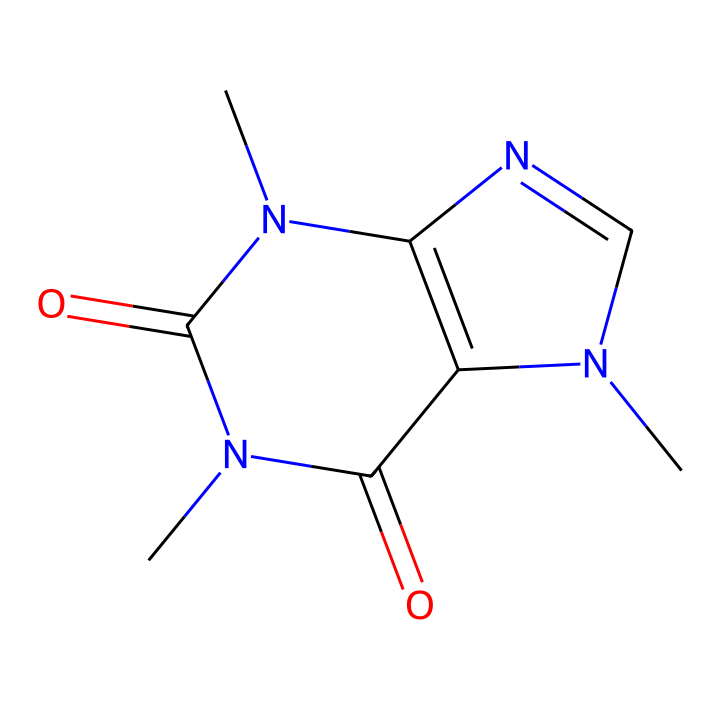How many nitrogen atoms are in the structure? The SMILES representation includes 'N' for nitrogen. By counting the 'N' characters in the sequence, we find there are four 'N' present.
Answer: four What is the functional group present in caffeine? The structure has multiple nitrogen atoms and a carbonyl group (C=O) indicating that caffeine is a derivative of amide compounds. The presence of these implies that it's an amide functional group.
Answer: amide What does the presence of carbonyl groups indicate? Carbonyl groups (C=O) are characteristic of compounds that can participate in hydrogen bonding and can influence the solubility and reactivity of the molecule, which is crucial for caffeine's role in energy drinks.
Answer: reactivity How many carbon atoms are in the chemical structure? By analyzing the carbon atoms present in the SMILES, we count them carefully and find a total of eight carbon atoms.
Answer: eight What type of compound is caffeine classified as? Caffeine is classified as an alkaloid; its structure consists of a complex arrangement of carbon, hydrogen, nitrogen, and oxygen atoms that produce notable physiological effects.
Answer: alkaloid What role does caffeine play in energy drinks? Caffeine is a stimulant that affects the central nervous system, increasing alertness and reducing the perception of fatigue, which is beneficial for those consuming energy drinks, especially among teens.
Answer: stimulant 